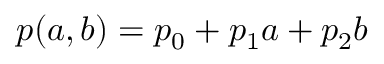Convert formula to latex. <formula><loc_0><loc_0><loc_500><loc_500>p ( a , b ) = p _ { 0 } + p _ { 1 } a + p _ { 2 } b</formula> 